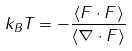Convert formula to latex. <formula><loc_0><loc_0><loc_500><loc_500>k _ { B } T = - \frac { \left \langle F \cdot F \right \rangle } { \left \langle \nabla \cdot F \right \rangle }</formula> 